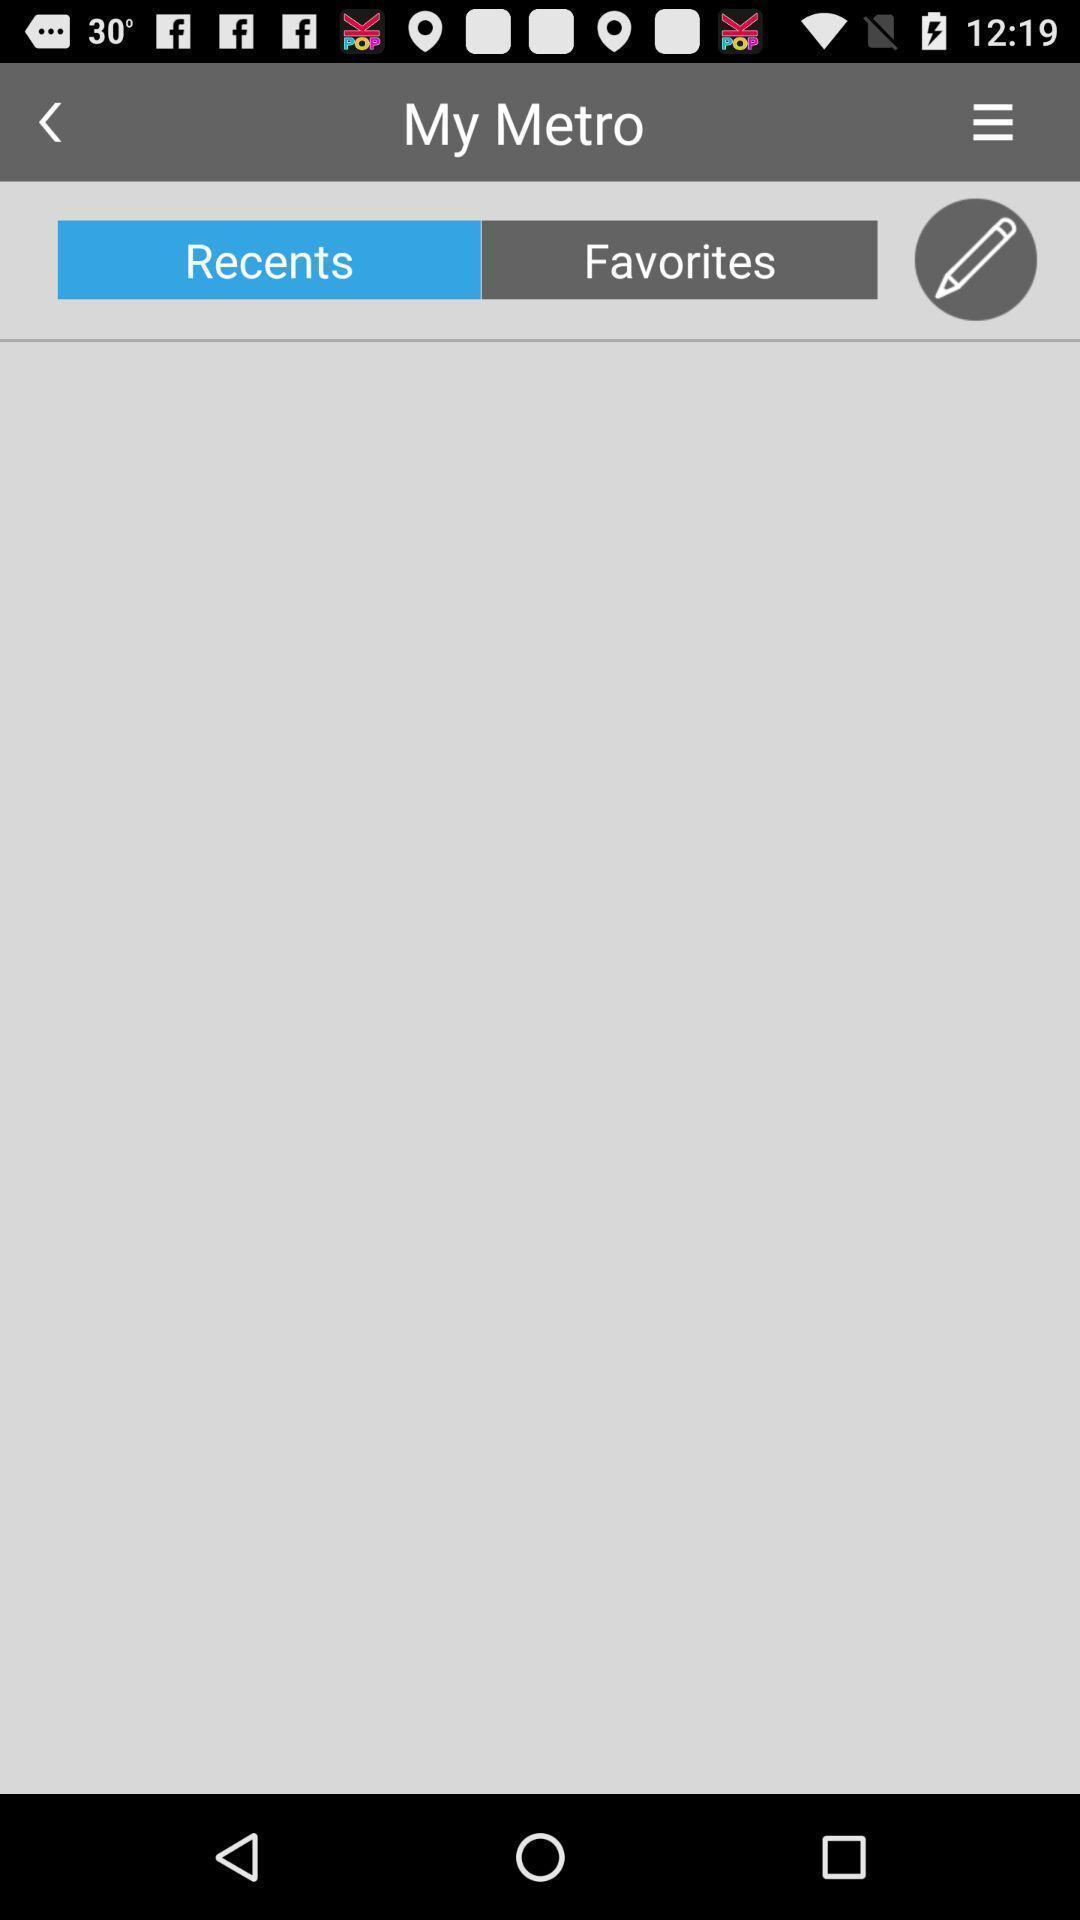Provide a detailed account of this screenshot. Screen showing recent trips in metro tracking app. 